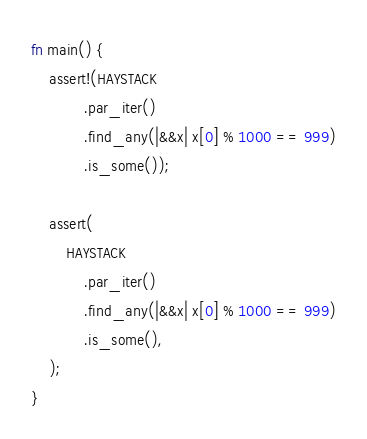Convert code to text. <code><loc_0><loc_0><loc_500><loc_500><_Rust_>fn main() {
    assert!(HAYSTACK
            .par_iter()
            .find_any(|&&x| x[0] % 1000 == 999)
            .is_some());

    assert(
        HAYSTACK
            .par_iter()
            .find_any(|&&x| x[0] % 1000 == 999)
            .is_some(),
    );
}
</code> 